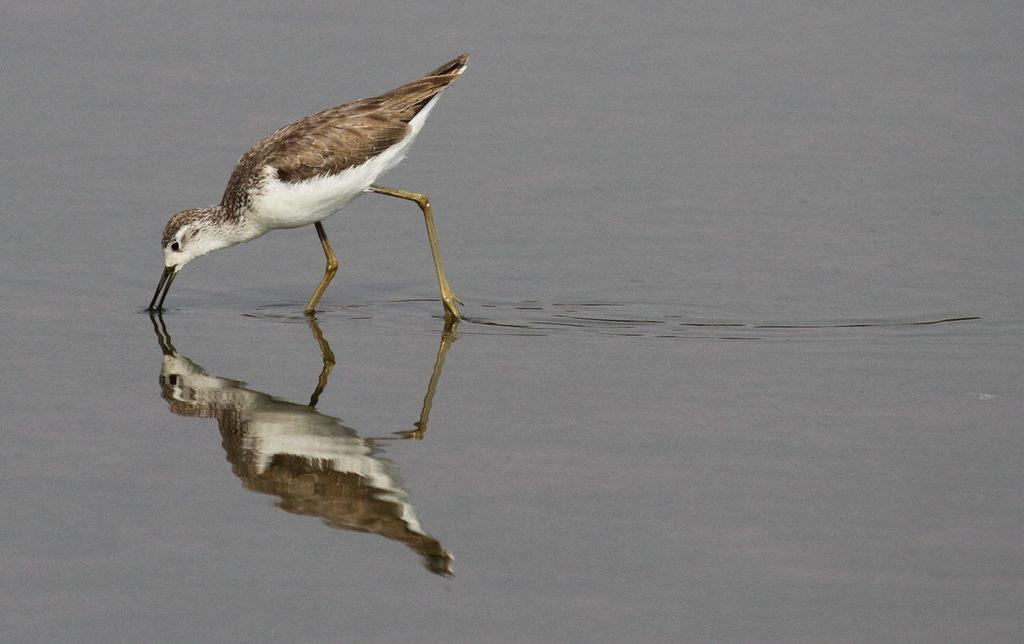Could you give a brief overview of what you see in this image? In this picture we can see water at the bottom, on the left side there is water, we can see reflection of this bird on the water. 